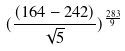<formula> <loc_0><loc_0><loc_500><loc_500>( \frac { ( 1 6 4 - 2 4 2 ) } { \sqrt { 5 } } ) ^ { \frac { 2 8 3 } { 9 } }</formula> 